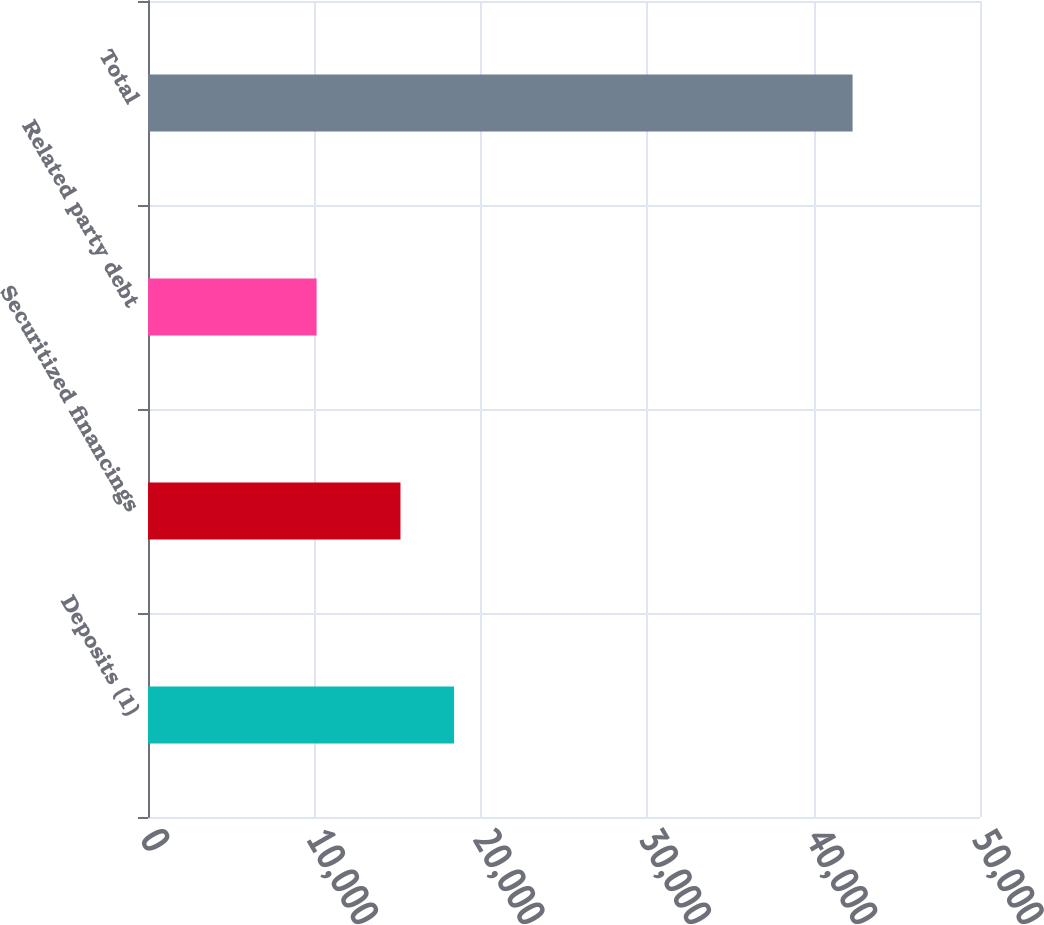Convert chart to OTSL. <chart><loc_0><loc_0><loc_500><loc_500><bar_chart><fcel>Deposits (1)<fcel>Securitized financings<fcel>Related party debt<fcel>Total<nl><fcel>18393.1<fcel>15172<fcel>10132<fcel>42343<nl></chart> 